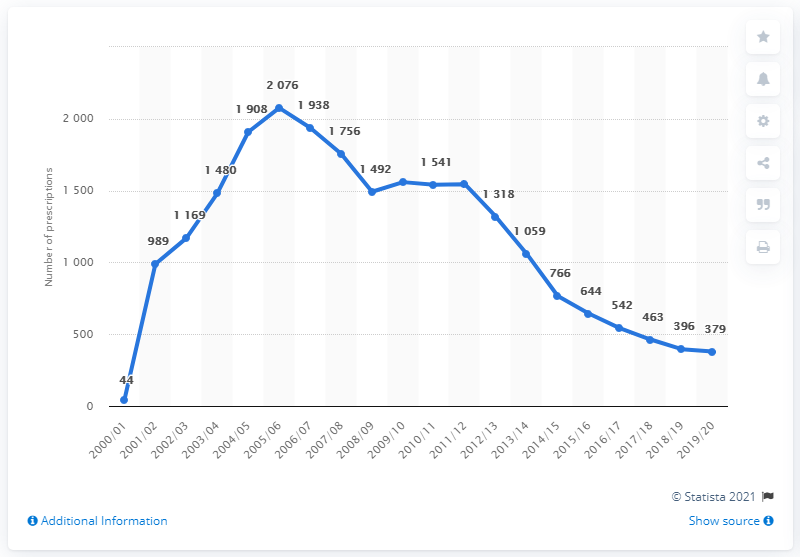Point out several critical features in this image. The average of the most recent four years of data is 445. The last data value in the line chart for the year 2020 is 379. 